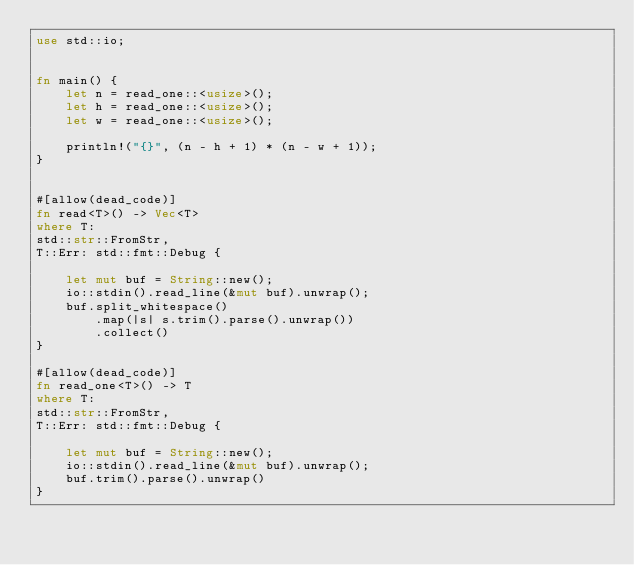Convert code to text. <code><loc_0><loc_0><loc_500><loc_500><_Rust_>use std::io;


fn main() {
    let n = read_one::<usize>();
    let h = read_one::<usize>();
    let w = read_one::<usize>();

    println!("{}", (n - h + 1) * (n - w + 1));
}


#[allow(dead_code)]
fn read<T>() -> Vec<T>
where T:
std::str::FromStr,
T::Err: std::fmt::Debug {

    let mut buf = String::new();
    io::stdin().read_line(&mut buf).unwrap();
    buf.split_whitespace()
        .map(|s| s.trim().parse().unwrap())
        .collect()
}

#[allow(dead_code)]
fn read_one<T>() -> T
where T:
std::str::FromStr,
T::Err: std::fmt::Debug {

    let mut buf = String::new();
    io::stdin().read_line(&mut buf).unwrap();
    buf.trim().parse().unwrap()
}</code> 